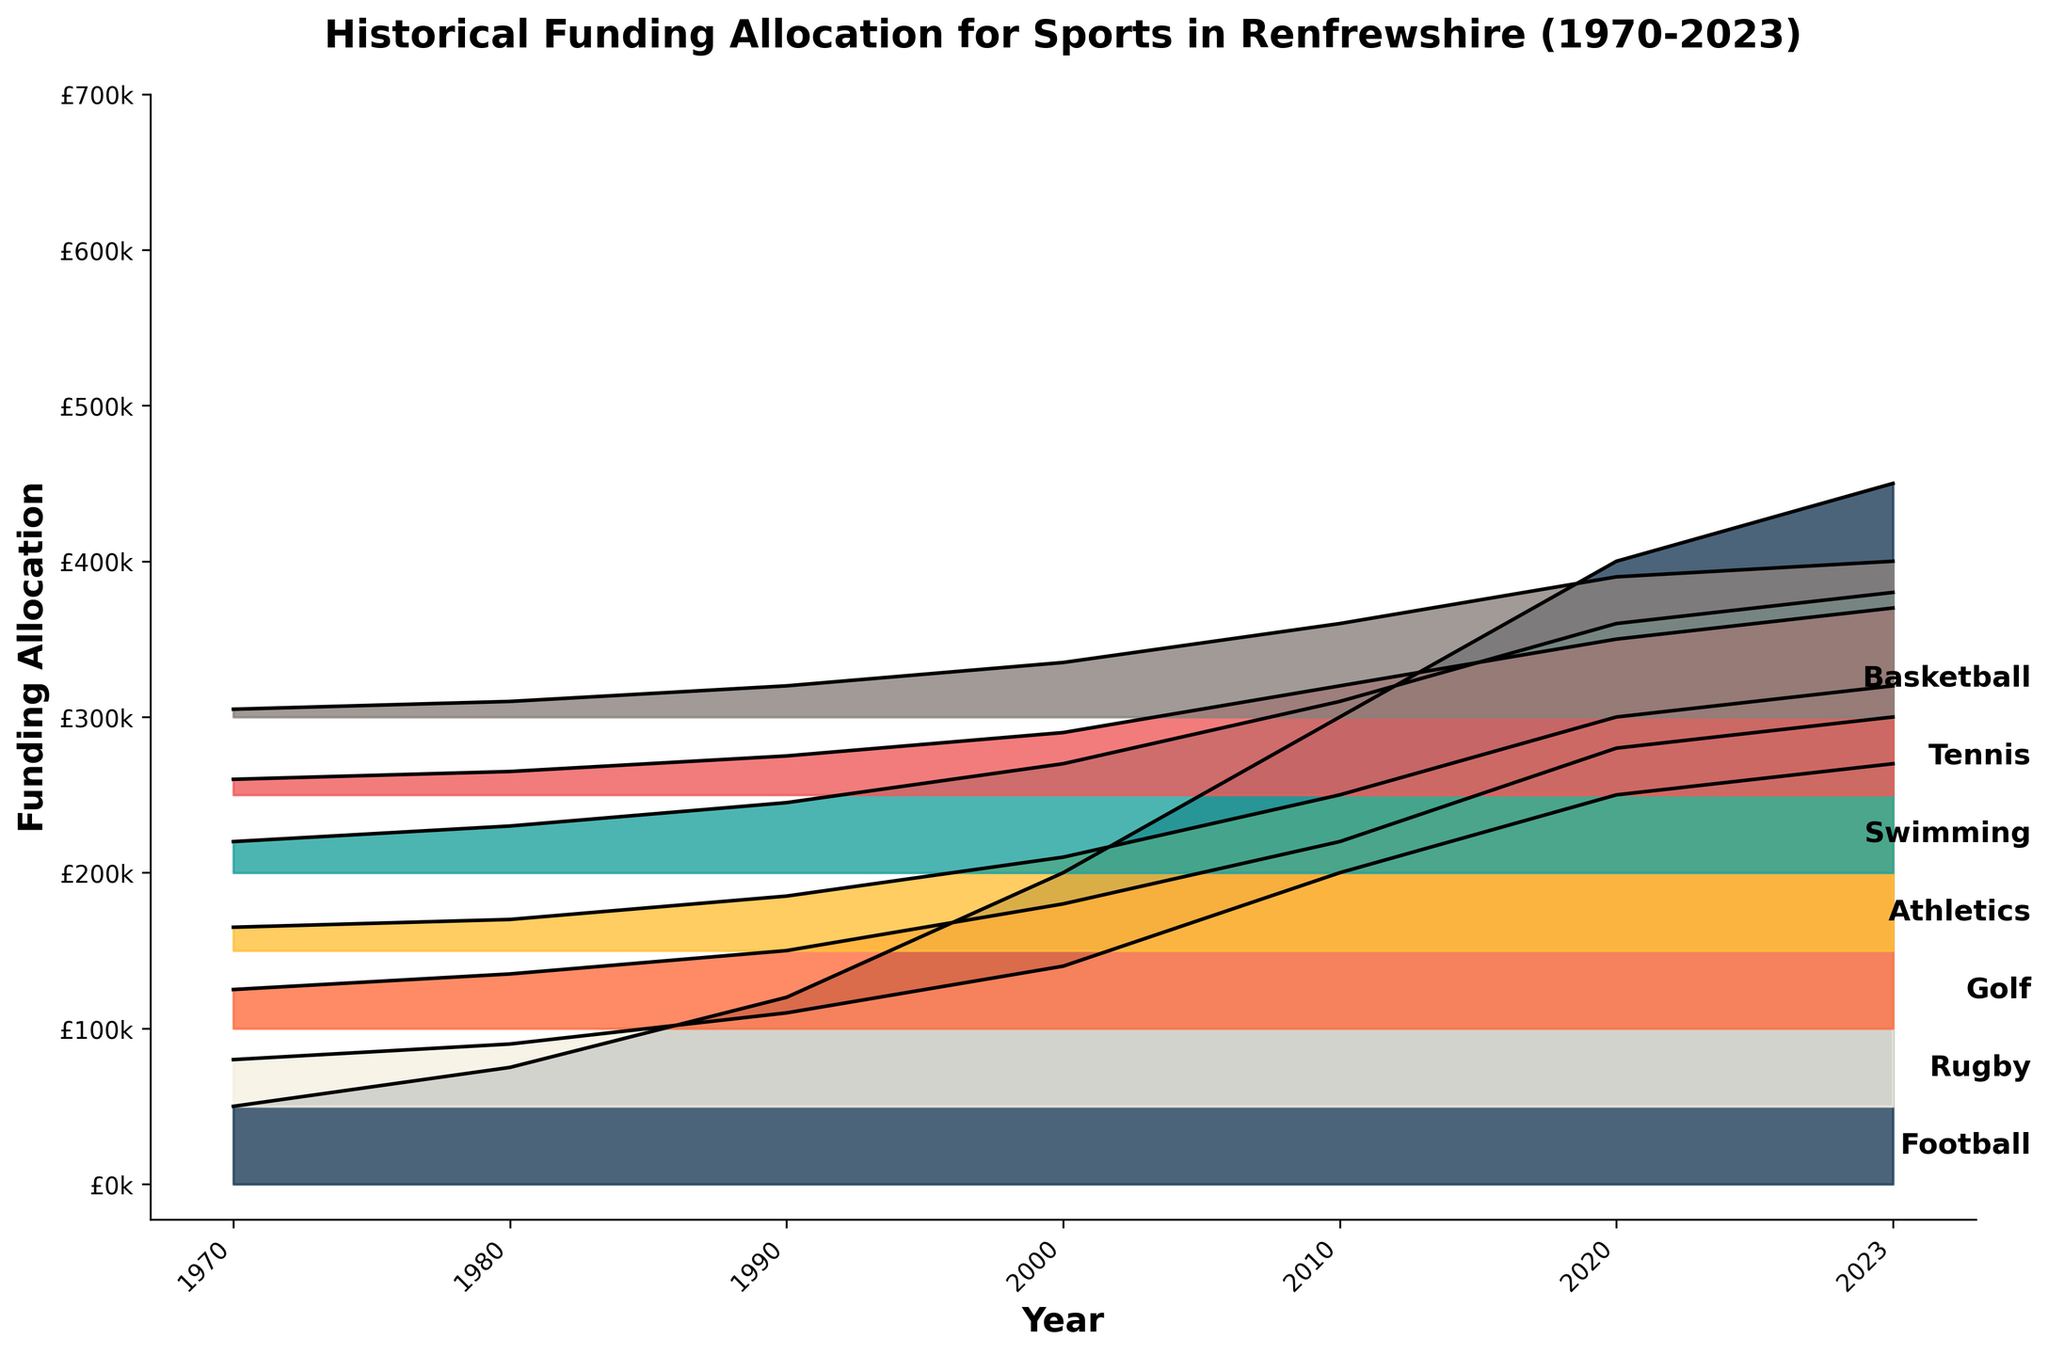What is the title of the figure? The title is usually found at the top of the plot and it summarizes the main subject of the plot. By examining the top part of the figure, you can read the text that is displayed.
Answer: Historical Funding Allocation for Sports in Renfrewshire (1970-2023) Which sport received the highest funding allocation in 2023? Look for the 2023 data points on the plot and identify which sport's curve is the highest above the others, indicating the largest funding allocation.
Answer: Football How has the funding for swimming changed from 1990 to 2023? Locate the points for swimming on the x-axis at the years 1990 and 2023, compare their heights above the baseline to determine the change.
Answer: Increased Between which years did Rugby experience the largest increase in funding? Examine the slopes of the Rugby funding curve between consecutive years, find the steepest positive slope to determine the largest increase.
Answer: 2000 to 2010 Which sport had the steepest increase in funding between 1970 and 1980? Look for the difference in heights between 1970 and 1980 for all sports and identify the sport with the largest increase.
Answer: Football Did any sport have a period of decreasing funding over the time span of the plot? Analyze the curves for any sport that dips downward between any two consecutive years to find any periods of decrease.
Answer: No What can be inferred about the general trend of funding allocations for Basketball over the years? Observe the Basketball funding curve from 1970 to 2023 to determine whether it generally slopes upward, downward, or remains flat.
Answer: Increasing How much funding was allocated to Golf in 2010 compared to Athletics in the same year? Find the points for Golf and Athletics in 2010 and compare their heights to estimate their respective funding allocations.
Answer: Golf: £120,000, Athletics: £100,000 By how much did the funding for Tennis grow from 1980 to 2020? Subtract the 1980 Tennis funding value from the 2020 Tennis funding value to determine the growth.
Answer: £100,000 Which year did Football funding surpass £400,000? Locate the year where the Football funding curve first crosses above the £400,000 mark on the y-axis.
Answer: 2020 